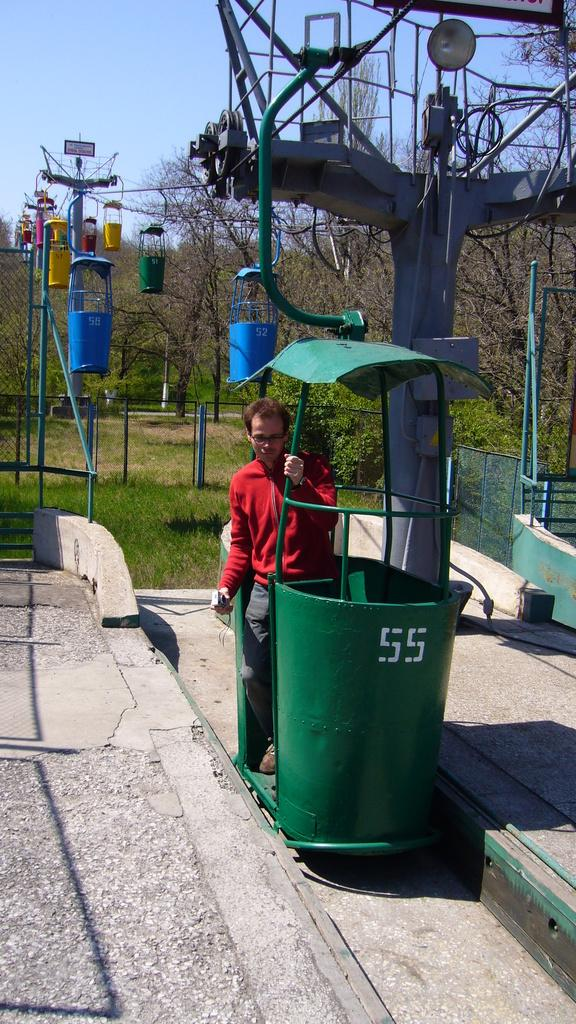Provide a one-sentence caption for the provided image. a man in front of a green bin with the numbers 55 on. 